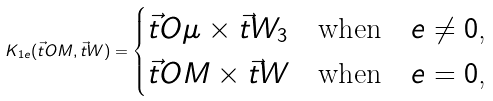<formula> <loc_0><loc_0><loc_500><loc_500>K _ { 1 e } ( \vec { t } { O M } , \vec { t } { W } ) = \begin{cases} \vec { t } { O \mu } \times \vec { t } { W _ { 3 } } & \text {when\quad $e\neq 0$,} \\ \vec { t } { O M } \times \vec { t } { W } & \text {when\quad $e=0$,} \end{cases}</formula> 